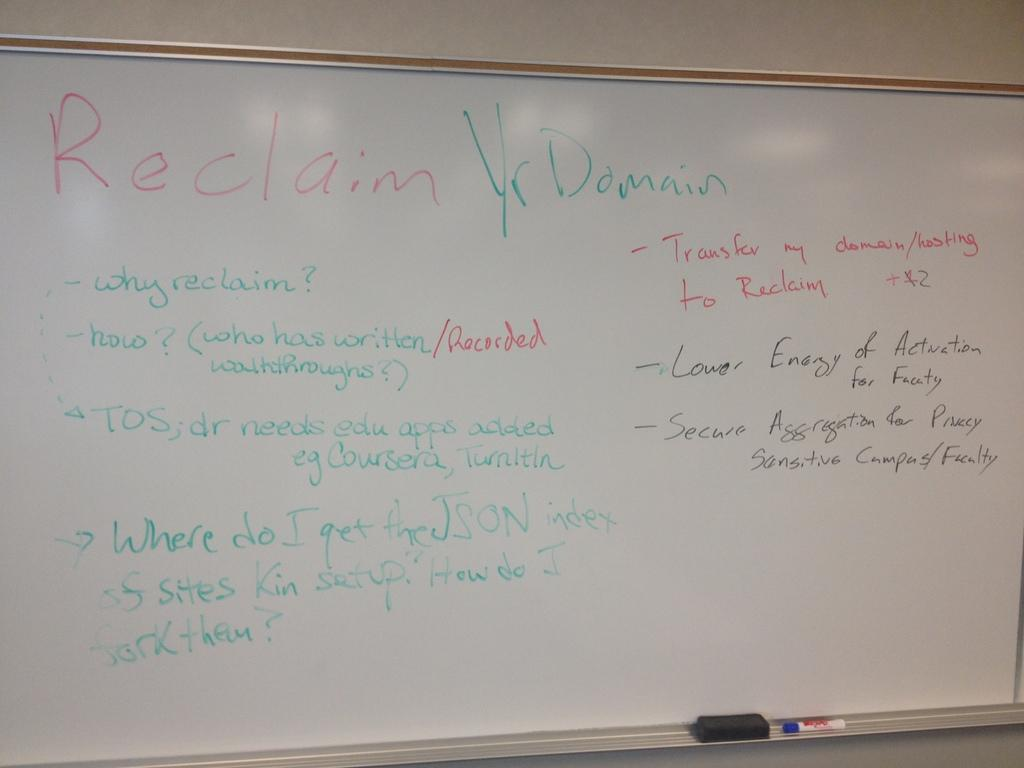<image>
Create a compact narrative representing the image presented. A class with a whiteboard with the words Reclaim written in red. 